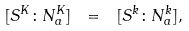Convert formula to latex. <formula><loc_0><loc_0><loc_500><loc_500>[ S ^ { K } \colon N _ { a } ^ { K } ] \ = \ [ S ^ { k } \colon N _ { a } ^ { k } ] ,</formula> 